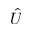<formula> <loc_0><loc_0><loc_500><loc_500>\hat { U }</formula> 